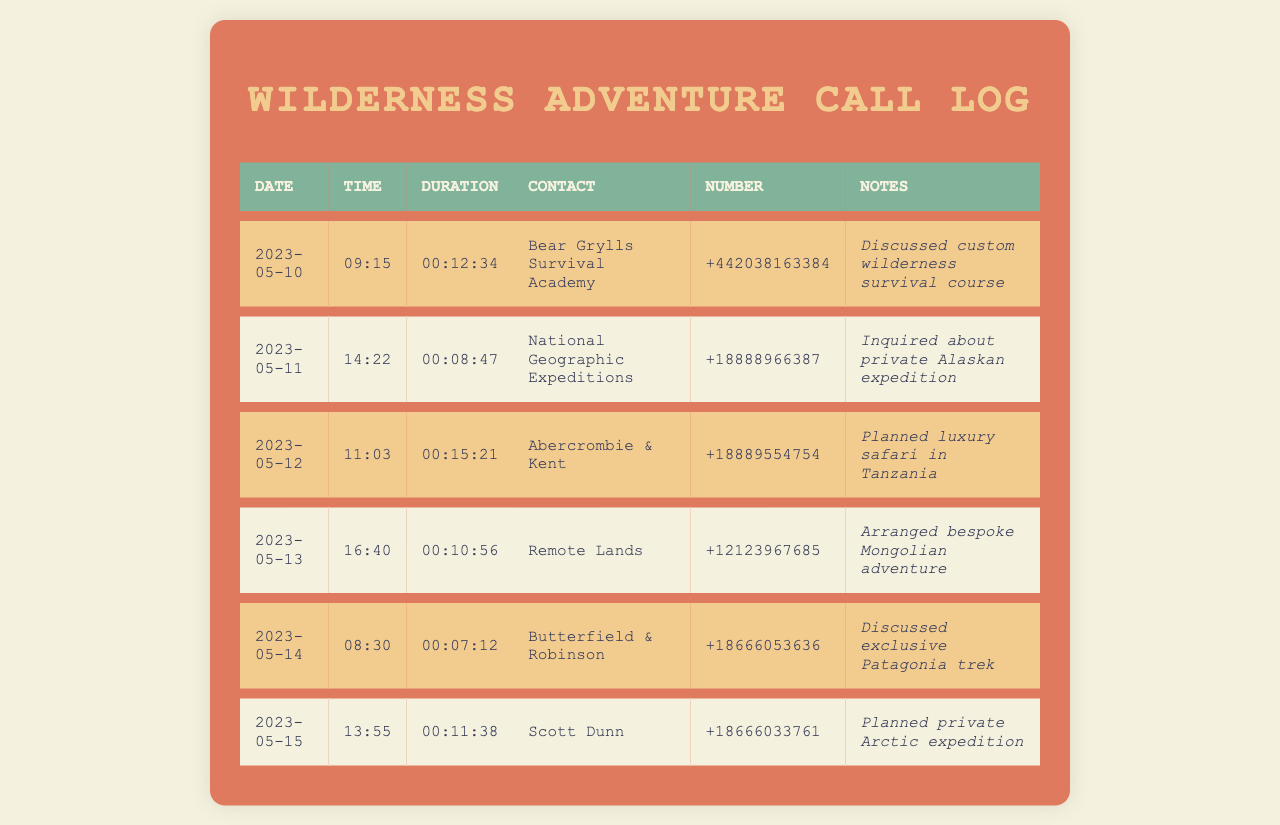what is the date of the first call? The first call in the log is on May 10, 2023.
Answer: May 10, 2023 who was called on May 12, 2023? The contact called on May 12, 2023, is Abercrombie & Kent.
Answer: Abercrombie & Kent how long did the call with Bear Grylls Survival Academy last? The duration of the call with Bear Grylls Survival Academy was 12 minutes and 34 seconds.
Answer: 00:12:34 which company was contacted regarding an exclusive Patagonia trek? The company contacted regarding the exclusive Patagonia trek is Butterfield & Robinson.
Answer: Butterfield & Robinson how many calls were made in total? There are six calls recorded in the log.
Answer: 6 which expedition was planned for private Arctic experience? The expedition planned for private Arctic experience involved Scott Dunn.
Answer: Scott Dunn what specific type of adventure was arranged with Remote Lands? The specific type of adventure arranged with Remote Lands is a bespoke Mongolian adventure.
Answer: bespoke Mongolian adventure what was the time of the last call? The time of the last call in the log was 13:55.
Answer: 13:55 which entity was inquired about for a private Alaskan expedition? The entity inquired about for a private Alaskan expedition was National Geographic Expeditions.
Answer: National Geographic Expeditions 